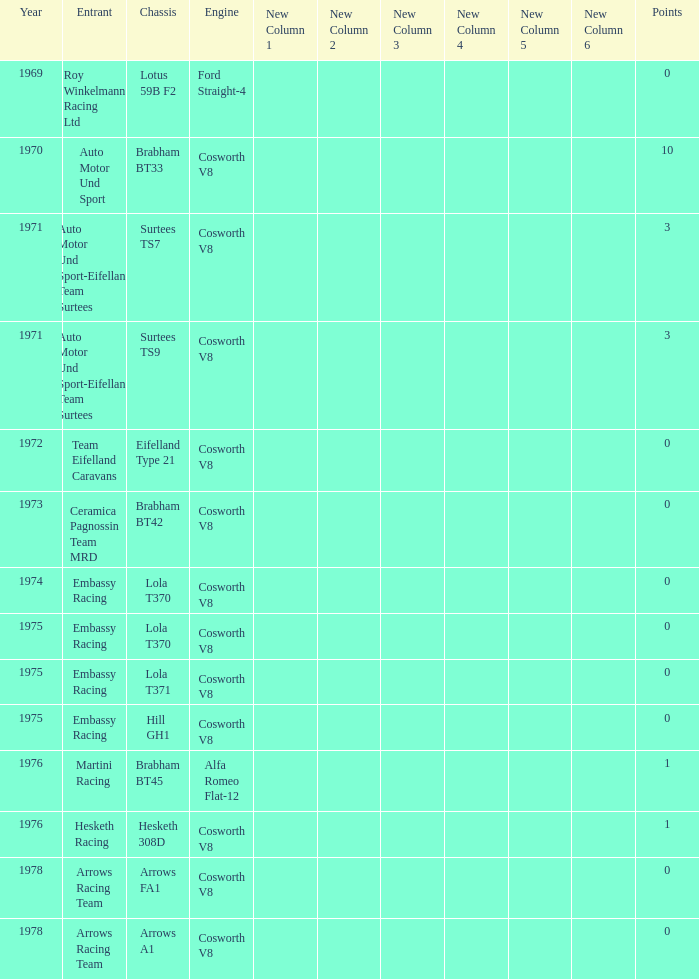Who was the entrant in 1971? Auto Motor Und Sport-Eifelland Team Surtees, Auto Motor Und Sport-Eifelland Team Surtees. 